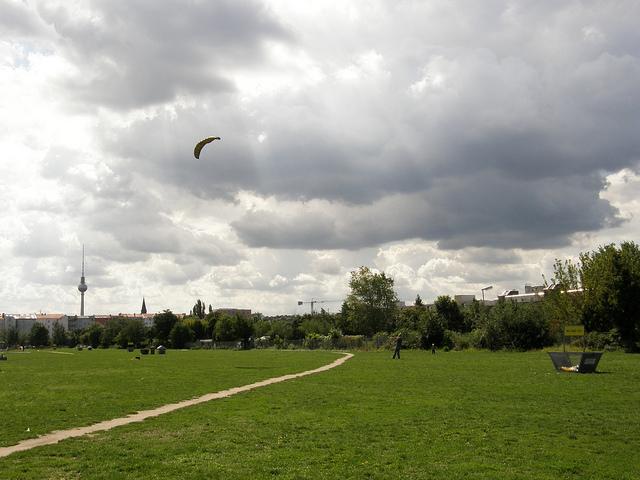What kind of day is this photo?
Keep it brief. Cloudy. Does this look like a sunny day?
Give a very brief answer. No. Is there a creek going through the field?
Give a very brief answer. No. What is the large tower off in the distance?
Short answer required. Space needle. What sensation is the kite-flying man feeling in his fingers?
Concise answer only. Numbness. Is it clear out?
Give a very brief answer. No. 